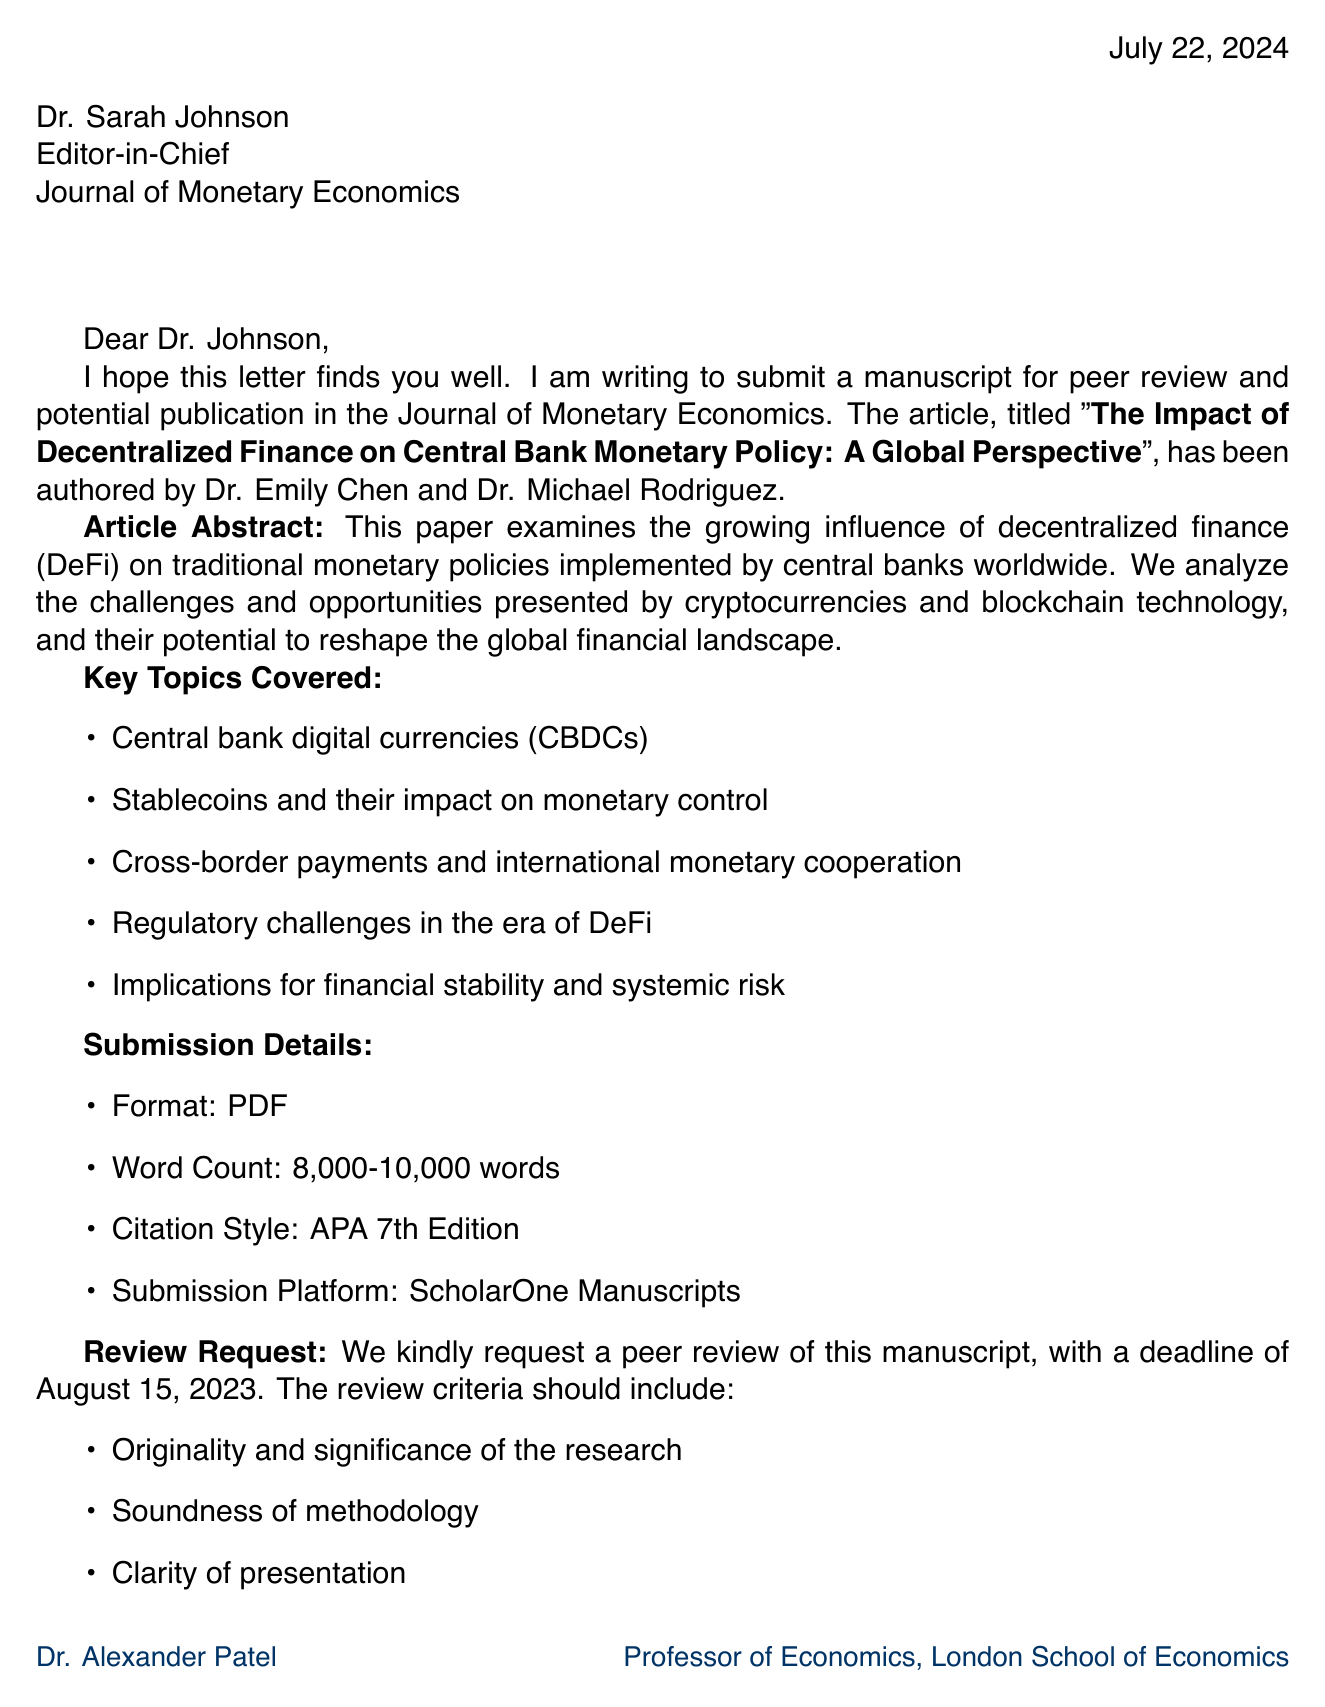What is the title of the article? The title of the article is mentioned in the introduction of the letter.
Answer: The Impact of Decentralized Finance on Central Bank Monetary Policy: A Global Perspective Who are the authors of the article? The authors of the article are listed right after the title.
Answer: Dr. Emily Chen, Dr. Michael Rodriguez What is the submission deadline for the peer review? The letter specifies a deadline for the peer review request.
Answer: August 15, 2023 How many words should the article contain? The submission details include the required word count for the article.
Answer: 8,000-10,000 words What format is required for the manuscript submission? The submission details indicate the format needed for the manuscript.
Answer: PDF What are one of the review criteria mentioned in the letter? Several review criteria are listed, and one is requested for the review process.
Answer: Originality and significance of the research Who is Dr. Alexander Patel? The letter describes the author of the letter, including his position and institution.
Answer: Professor of Economics, London School of Economics Name a suggested reviewer from the letter. Potential reviewers are suggested in the letter, and one name is requested.
Answer: Dr. Lisa Nakamoto What is a key topic covered in the article? Key topics are listed in the letter and one can be identified easily.
Answer: Central bank digital currencies (CBDCs) What platform should the article be submitted to? The submission details include the platform for manuscript submission.
Answer: ScholarOne Manuscripts 